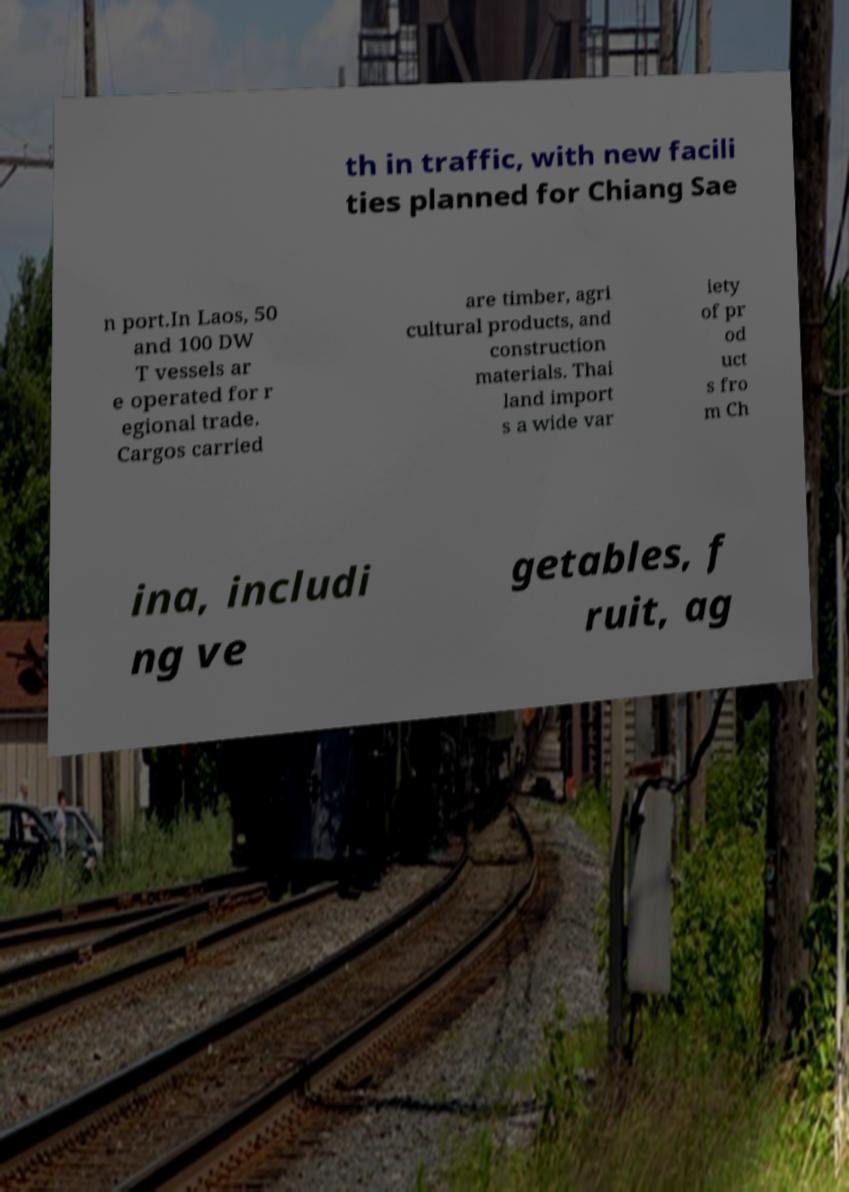Could you extract and type out the text from this image? th in traffic, with new facili ties planned for Chiang Sae n port.In Laos, 50 and 100 DW T vessels ar e operated for r egional trade. Cargos carried are timber, agri cultural products, and construction materials. Thai land import s a wide var iety of pr od uct s fro m Ch ina, includi ng ve getables, f ruit, ag 